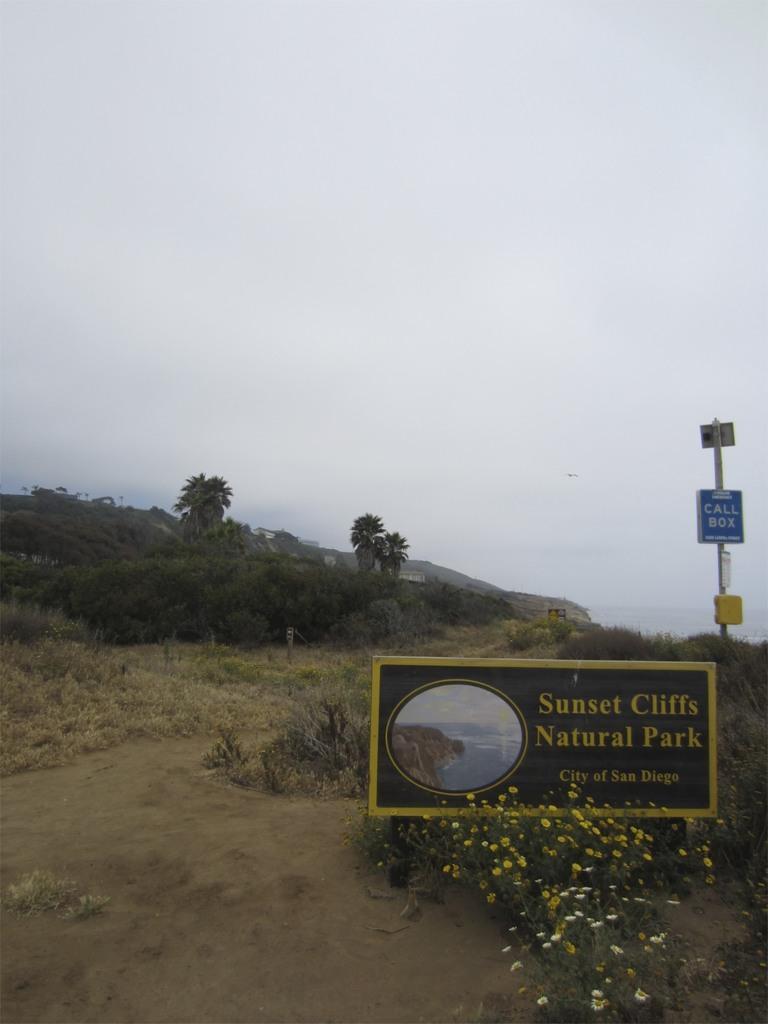Describe this image in one or two sentences. In this image we can see name board, pole, trees, plants, grass, flowers, house, hill, sky and clouds. 